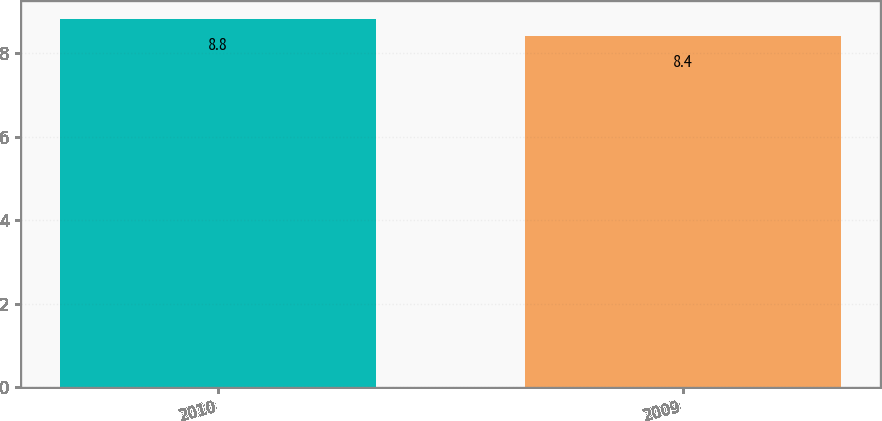Convert chart. <chart><loc_0><loc_0><loc_500><loc_500><bar_chart><fcel>2010<fcel>2009<nl><fcel>8.8<fcel>8.4<nl></chart> 